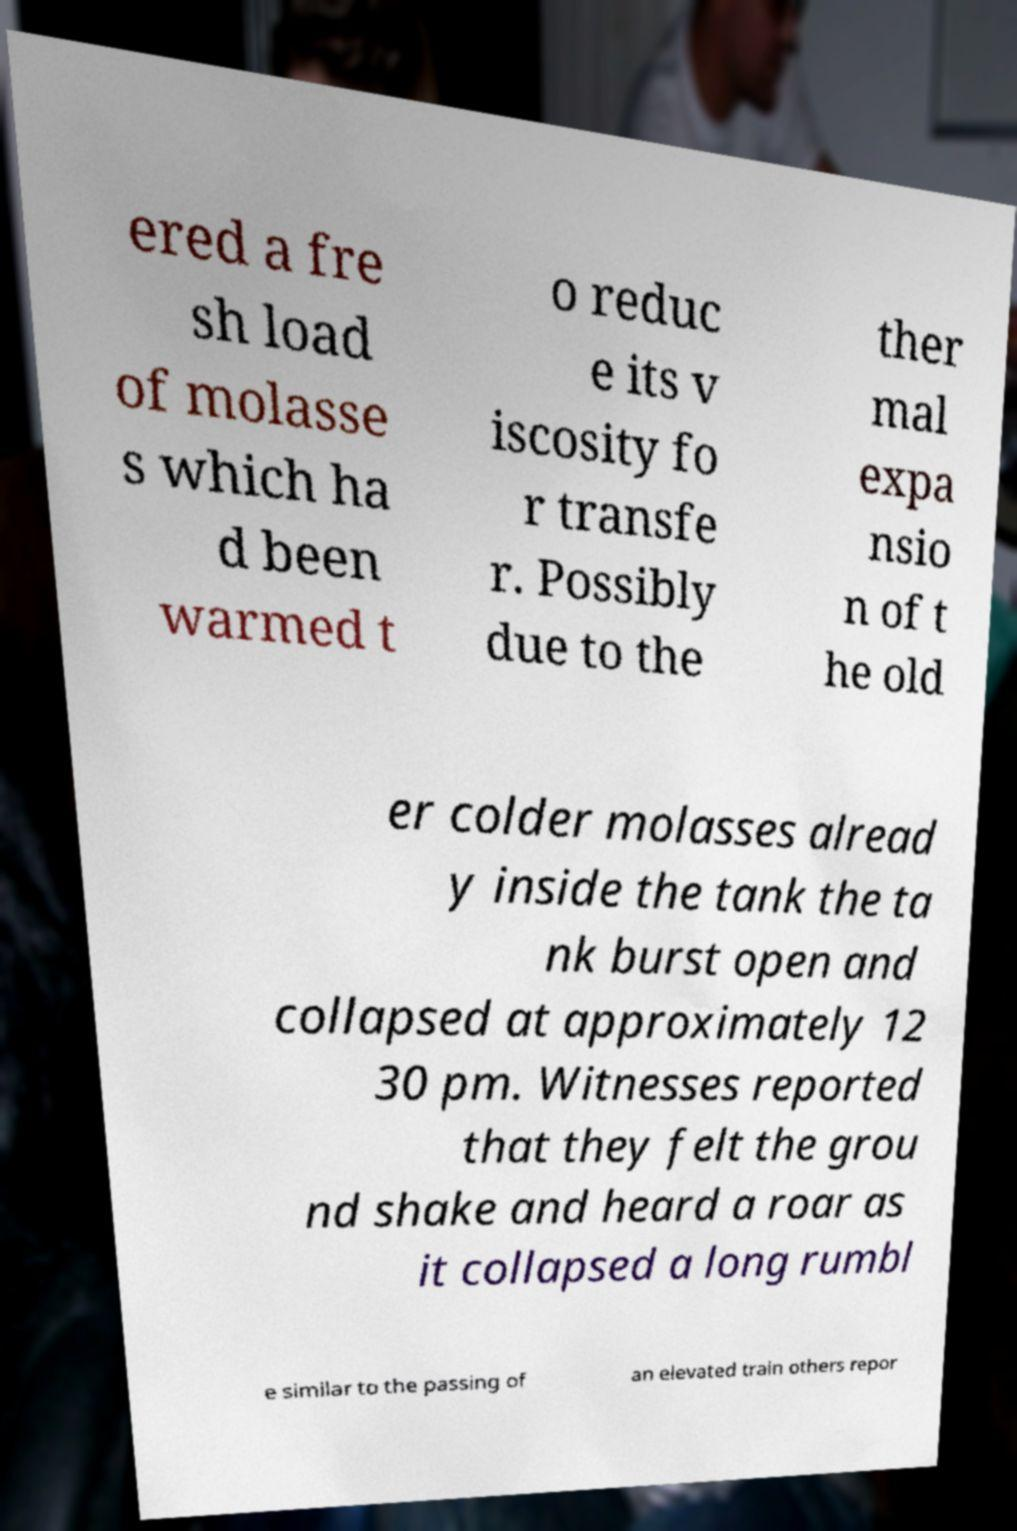I need the written content from this picture converted into text. Can you do that? ered a fre sh load of molasse s which ha d been warmed t o reduc e its v iscosity fo r transfe r. Possibly due to the ther mal expa nsio n of t he old er colder molasses alread y inside the tank the ta nk burst open and collapsed at approximately 12 30 pm. Witnesses reported that they felt the grou nd shake and heard a roar as it collapsed a long rumbl e similar to the passing of an elevated train others repor 